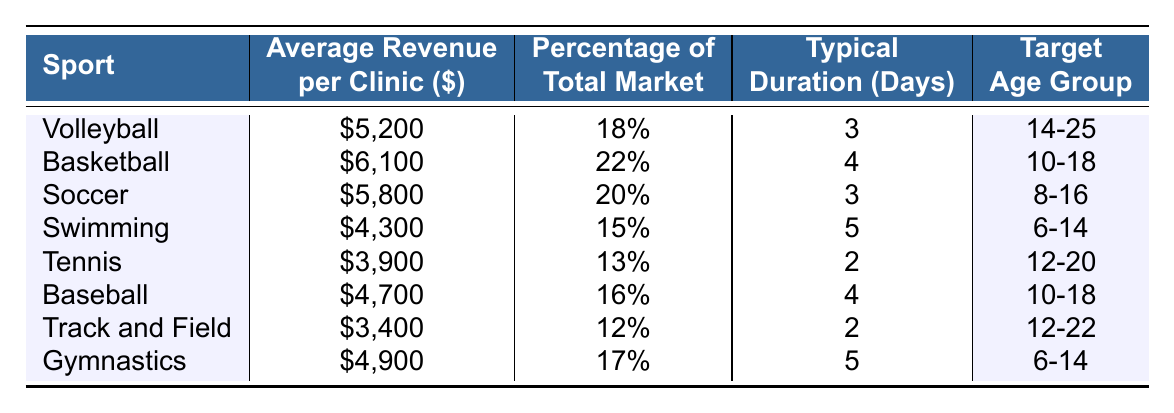What is the average revenue per clinic for volleyball? The table shows that the average revenue per clinic for volleyball is listed as $5,200.
Answer: $5,200 Which sport has the highest percentage of the total market? According to the table, basketball has the highest percentage at 22%.
Answer: 22% What is the typical duration of a swimming clinic? The table indicates that a swimming clinic typically lasts for 5 days.
Answer: 5 days Is the average revenue for gymnastics higher than that for tennis? The average revenue for gymnastics is $4,900 and for tennis is $3,900. Since $4,900 is greater than $3,900, the statement is true.
Answer: Yes Calculate the total average revenue for soccer and baseball clinics. The average revenue for soccer is $5,800 and for baseball is $4,700. Summing them up gives $5,800 + $4,700 = $10,500.
Answer: $10,500 Which sport has the lowest average revenue per clinic? By reviewing the table, track and field has the lowest average revenue at $3,400.
Answer: Track and Field How many days longer is the typical duration of a swimming clinic compared to a tennis clinic? A swimming clinic lasts 5 days, while a tennis clinic lasts 2 days. The difference is 5 - 2 = 3 days.
Answer: 3 days True or false: The target age group for baseball clinics is older than that for volleyball clinics. The target age group for baseball is 10-18, while for volleyball it is 14-25. Since 14 is greater than 10 and 25 is greater than 18, the statement is false.
Answer: False What is the average revenue per clinic for soccer relative to its percentage of total market? The average revenue for soccer is $5,800, and it represents 20% of the total market. This shows soccer has a moderate revenue relative to its market size.
Answer: $5,800, 20% If you wanted to target age groups 6-14 and 12-20, which sports clinics would you consider? From the table, swimming and gymnastics target the age group of 6-14, while tennis targets 12-20. Both can be considered for those age ranges.
Answer: Swimming, Gymnastics, Tennis 